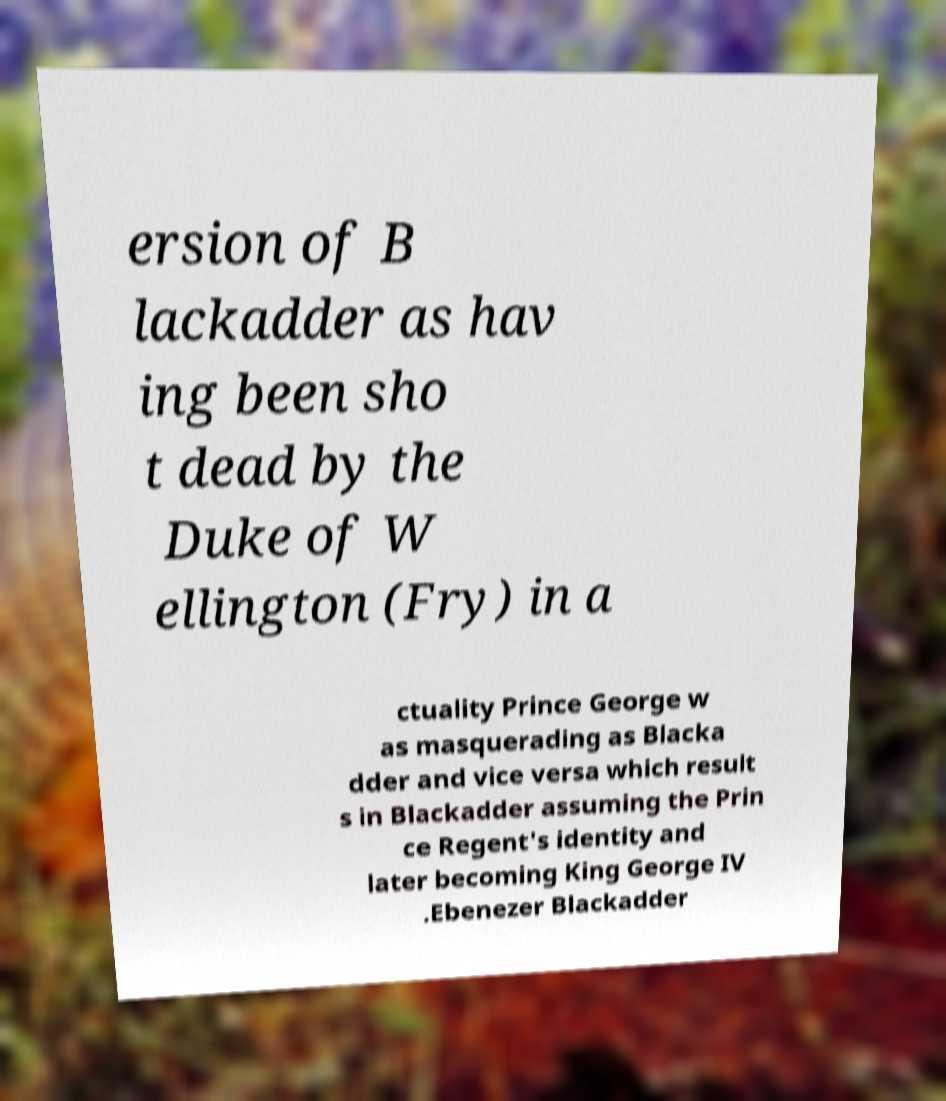For documentation purposes, I need the text within this image transcribed. Could you provide that? ersion of B lackadder as hav ing been sho t dead by the Duke of W ellington (Fry) in a ctuality Prince George w as masquerading as Blacka dder and vice versa which result s in Blackadder assuming the Prin ce Regent's identity and later becoming King George IV .Ebenezer Blackadder 